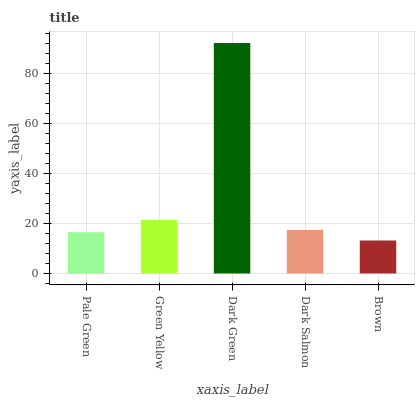Is Green Yellow the minimum?
Answer yes or no. No. Is Green Yellow the maximum?
Answer yes or no. No. Is Green Yellow greater than Pale Green?
Answer yes or no. Yes. Is Pale Green less than Green Yellow?
Answer yes or no. Yes. Is Pale Green greater than Green Yellow?
Answer yes or no. No. Is Green Yellow less than Pale Green?
Answer yes or no. No. Is Dark Salmon the high median?
Answer yes or no. Yes. Is Dark Salmon the low median?
Answer yes or no. Yes. Is Pale Green the high median?
Answer yes or no. No. Is Green Yellow the low median?
Answer yes or no. No. 